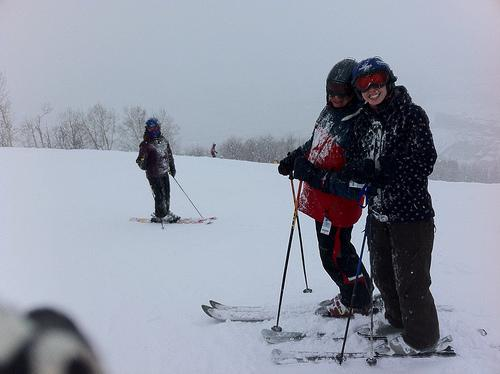Question: how many pairs of skis are shown?
Choices:
A. 3.
B. 2.
C. 4.
D. 5.
Answer with the letter. Answer: B Question: how many pairs of skis are visible?
Choices:
A. 3.
B. 2.
C. 4.
D. 5.
Answer with the letter. Answer: A Question: where are there trees?
Choices:
A. In the background.
B. To the left.
C. On the hill.
D. On the left.
Answer with the letter. Answer: D Question: why are they wearing jackets?
Choices:
A. Raining.
B. It is fall.
C. Protect from wind.
D. It's cold outside.
Answer with the letter. Answer: D 